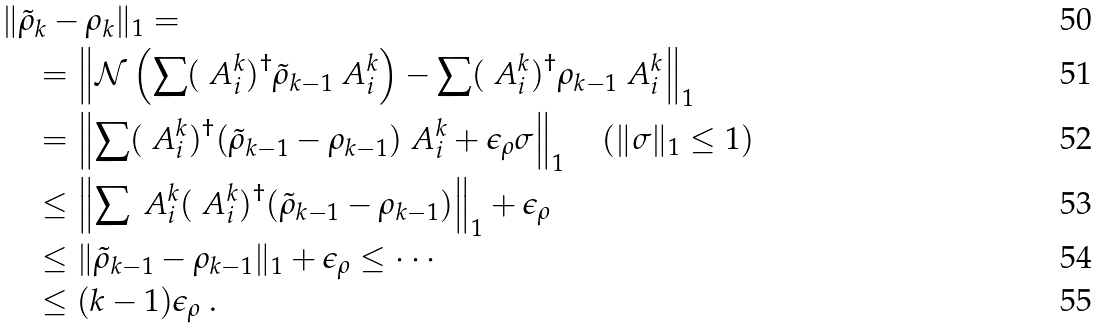Convert formula to latex. <formula><loc_0><loc_0><loc_500><loc_500>& \| \tilde { \rho } _ { k } - \rho _ { k } \| _ { 1 } = \\ & \quad = \left \| \mathcal { N } \left ( \sum ( \ A _ { i } ^ { k } ) ^ { \dagger } \tilde { \rho } _ { k - 1 } \ A _ { i } ^ { k } \right ) - \sum ( \ A _ { i } ^ { k } ) ^ { \dagger } \rho _ { k - 1 } \ A _ { i } ^ { k } \right \| _ { 1 } \\ & \quad = \left \| \sum ( \ A _ { i } ^ { k } ) ^ { \dagger } ( \tilde { \rho } _ { k - 1 } - \rho _ { k - 1 } ) \ A _ { i } ^ { k } + \epsilon _ { \rho } \sigma \right \| _ { 1 } \quad ( \| \sigma \| _ { 1 } \leq 1 ) \\ & \quad \leq \left \| \sum \ A _ { i } ^ { k } ( \ A _ { i } ^ { k } ) ^ { \dagger } ( \tilde { \rho } _ { k - 1 } - \rho _ { k - 1 } ) \right \| _ { 1 } + \epsilon _ { \rho } \\ & \quad \leq \| \tilde { \rho } _ { k - 1 } - \rho _ { k - 1 } \| _ { 1 } + \epsilon _ { \rho } \leq \cdots \\ & \quad \leq ( k - 1 ) \epsilon _ { \rho } \ .</formula> 